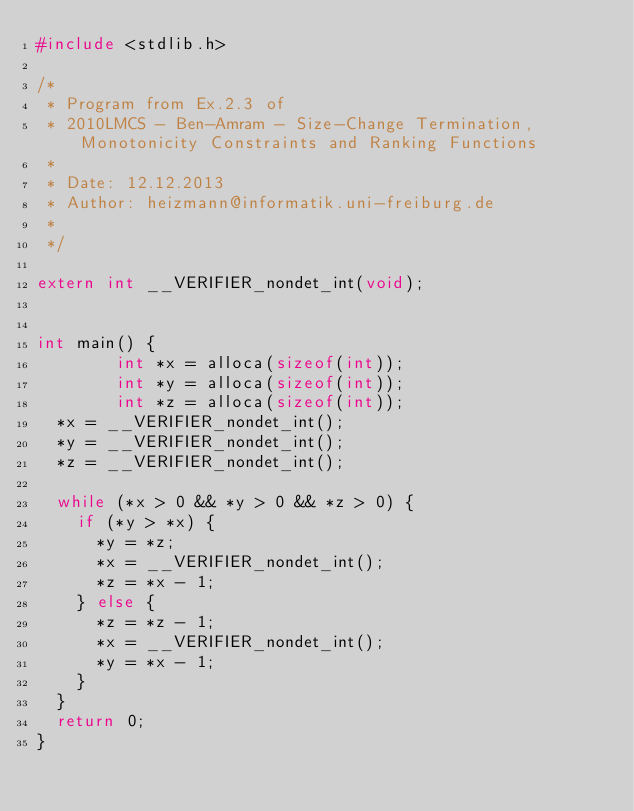<code> <loc_0><loc_0><loc_500><loc_500><_C_>#include <stdlib.h>

/*
 * Program from Ex.2.3 of
 * 2010LMCS - Ben-Amram - Size-Change Termination, Monotonicity Constraints and Ranking Functions
 *
 * Date: 12.12.2013
 * Author: heizmann@informatik.uni-freiburg.de
 *
 */

extern int __VERIFIER_nondet_int(void);


int main() {
        int *x = alloca(sizeof(int));
        int *y = alloca(sizeof(int));
        int *z = alloca(sizeof(int));
	*x = __VERIFIER_nondet_int();
	*y = __VERIFIER_nondet_int();
	*z = __VERIFIER_nondet_int();

	while (*x > 0 && *y > 0 && *z > 0) {
		if (*y > *x) {
			*y = *z;
			*x = __VERIFIER_nondet_int();
			*z = *x - 1;
		} else {
			*z = *z - 1;
			*x = __VERIFIER_nondet_int();
			*y = *x - 1;
		}
	}
	return 0;
}
</code> 